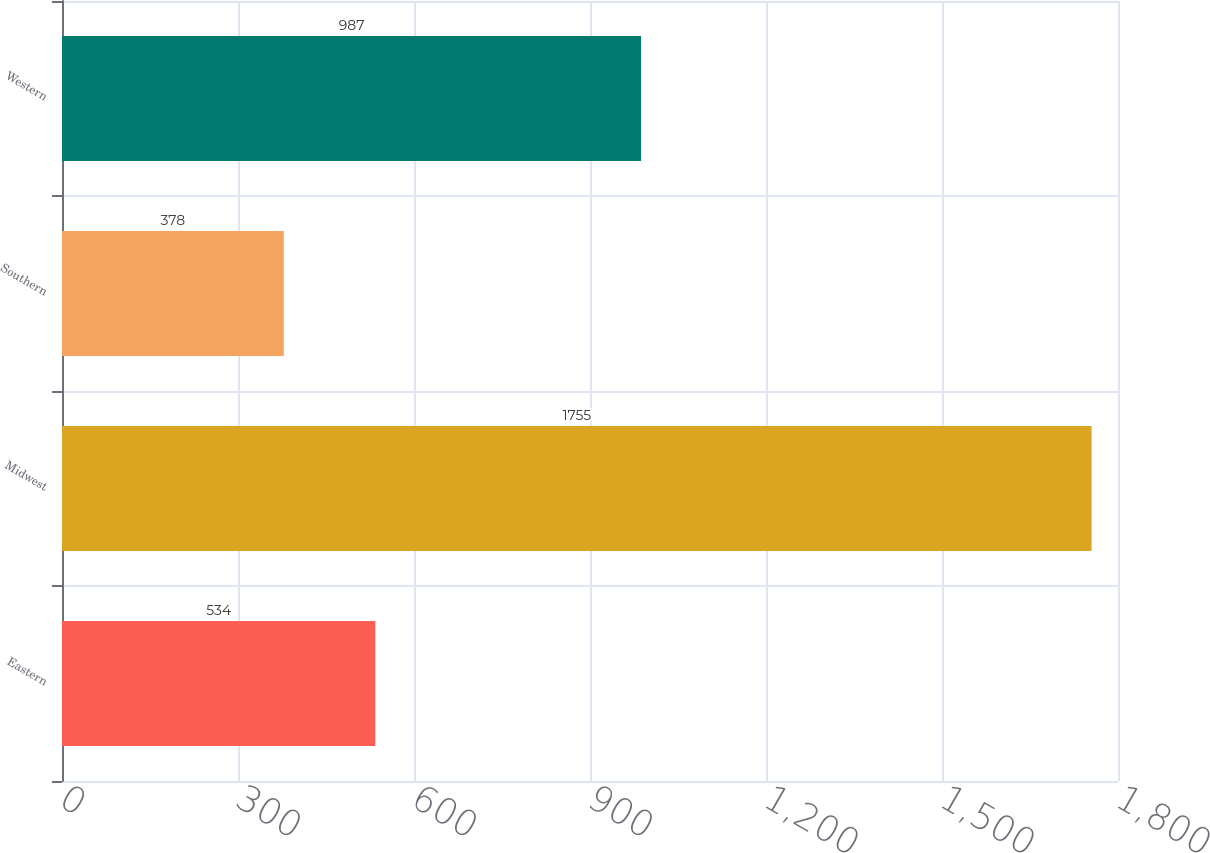<chart> <loc_0><loc_0><loc_500><loc_500><bar_chart><fcel>Eastern<fcel>Midwest<fcel>Southern<fcel>Western<nl><fcel>534<fcel>1755<fcel>378<fcel>987<nl></chart> 